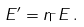Convert formula to latex. <formula><loc_0><loc_0><loc_500><loc_500>E ^ { \prime } = r _ { \Gamma } E \, .</formula> 